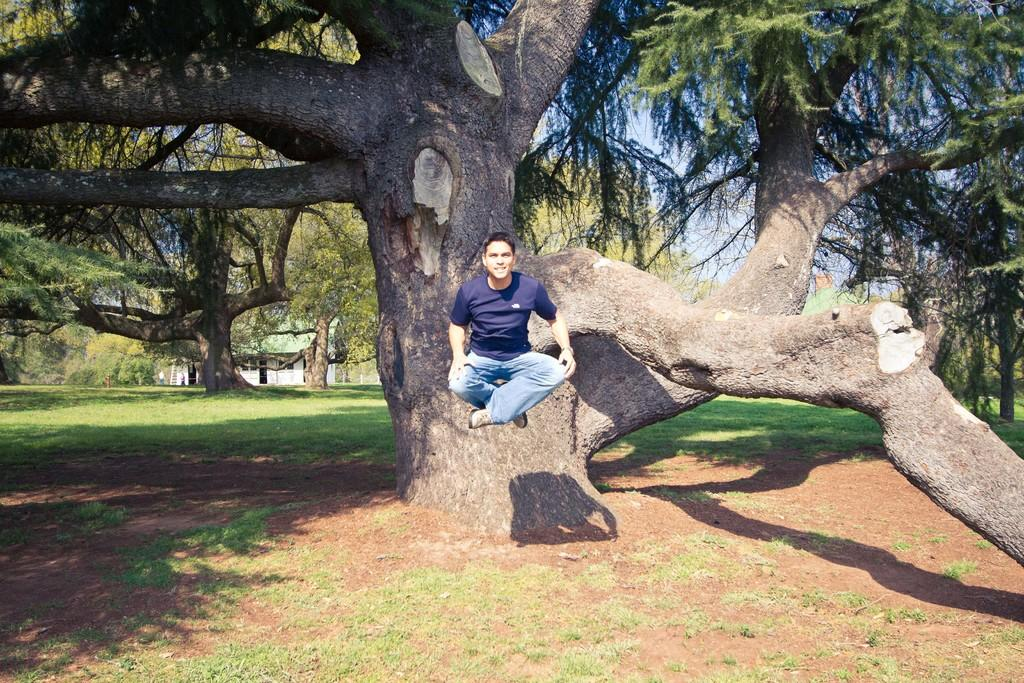Who is present in the image? There is a person in the image. What is the person doing in the image? The person is jumping. What can be seen in the background of the image? There are trees, a building, and the sky visible in the background of the image. What type of sheet is being used for digestion in the image? There is no sheet or reference to digestion present in the image. 